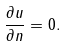Convert formula to latex. <formula><loc_0><loc_0><loc_500><loc_500>\frac { \partial u } { \partial n } = 0 .</formula> 